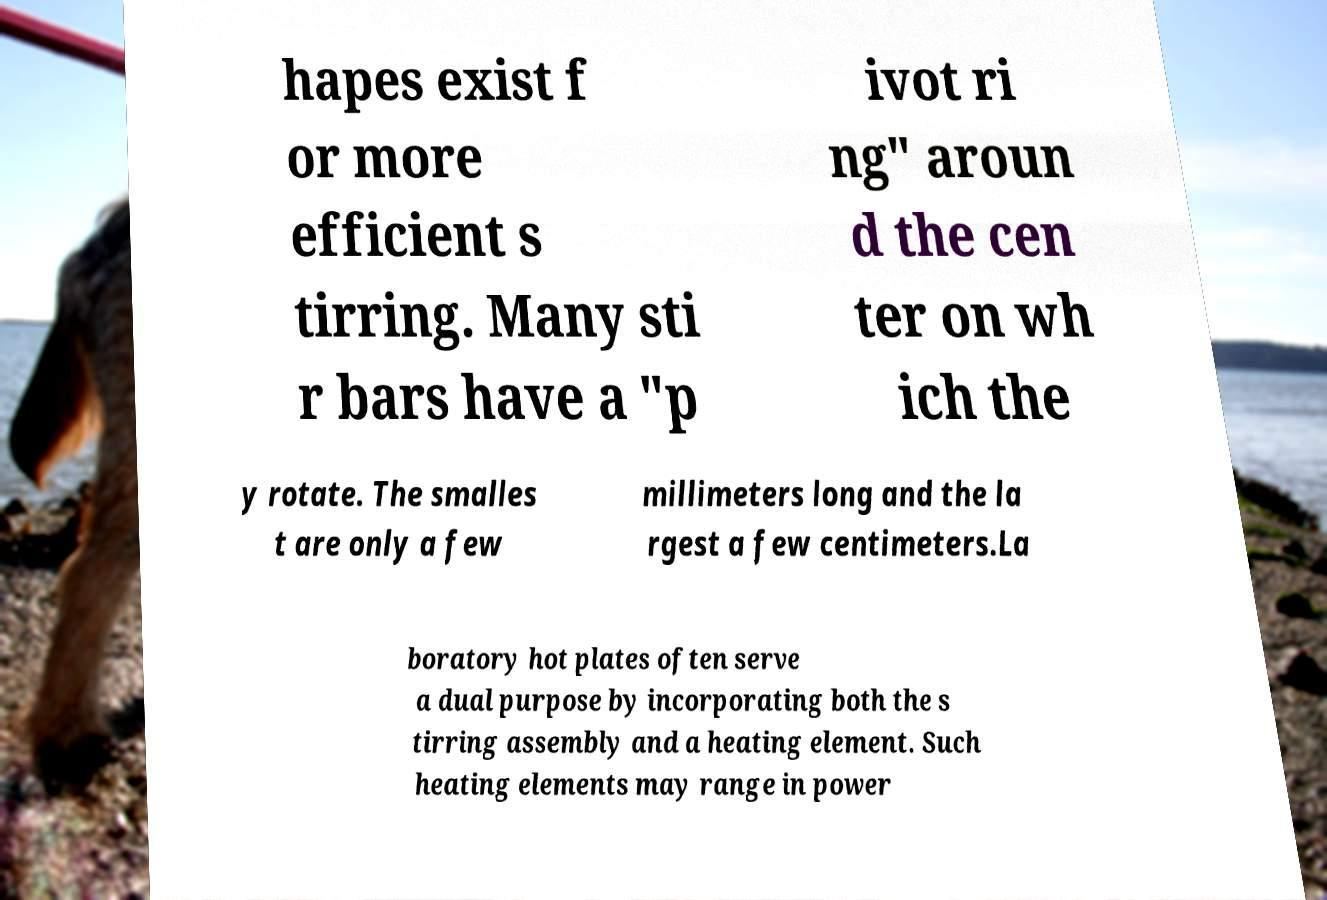What messages or text are displayed in this image? I need them in a readable, typed format. hapes exist f or more efficient s tirring. Many sti r bars have a "p ivot ri ng" aroun d the cen ter on wh ich the y rotate. The smalles t are only a few millimeters long and the la rgest a few centimeters.La boratory hot plates often serve a dual purpose by incorporating both the s tirring assembly and a heating element. Such heating elements may range in power 